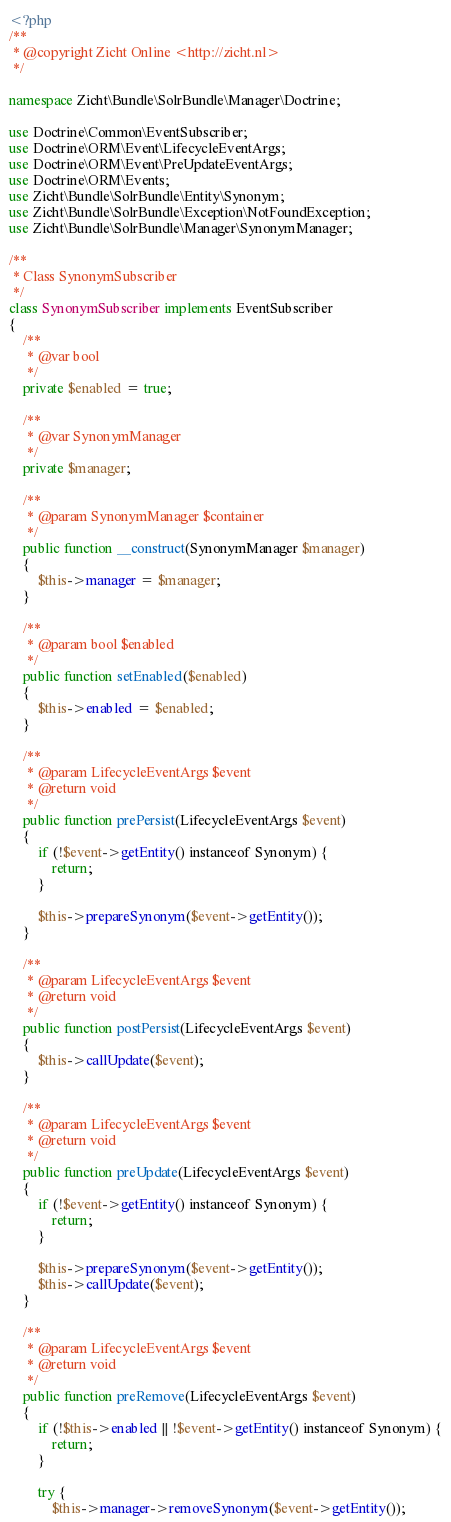<code> <loc_0><loc_0><loc_500><loc_500><_PHP_><?php
/**
 * @copyright Zicht Online <http://zicht.nl>
 */

namespace Zicht\Bundle\SolrBundle\Manager\Doctrine;

use Doctrine\Common\EventSubscriber;
use Doctrine\ORM\Event\LifecycleEventArgs;
use Doctrine\ORM\Event\PreUpdateEventArgs;
use Doctrine\ORM\Events;
use Zicht\Bundle\SolrBundle\Entity\Synonym;
use Zicht\Bundle\SolrBundle\Exception\NotFoundException;
use Zicht\Bundle\SolrBundle\Manager\SynonymManager;

/**
 * Class SynonymSubscriber
 */
class SynonymSubscriber implements EventSubscriber
{
    /**
     * @var bool
     */
    private $enabled = true;

    /**
     * @var SynonymManager
     */
    private $manager;

    /**
     * @param SynonymManager $container
     */
    public function __construct(SynonymManager $manager)
    {
        $this->manager = $manager;
    }

    /**
     * @param bool $enabled
     */
    public function setEnabled($enabled)
    {
        $this->enabled = $enabled;
    }

    /**
     * @param LifecycleEventArgs $event
     * @return void
     */
    public function prePersist(LifecycleEventArgs $event)
    {
        if (!$event->getEntity() instanceof Synonym) {
            return;
        }

        $this->prepareSynonym($event->getEntity());
    }

    /**
     * @param LifecycleEventArgs $event
     * @return void
     */
    public function postPersist(LifecycleEventArgs $event)
    {
        $this->callUpdate($event);
    }

    /**
     * @param LifecycleEventArgs $event
     * @return void
     */
    public function preUpdate(LifecycleEventArgs $event)
    {
        if (!$event->getEntity() instanceof Synonym) {
            return;
        }

        $this->prepareSynonym($event->getEntity());
        $this->callUpdate($event);
    }

    /**
     * @param LifecycleEventArgs $event
     * @return void
     */
    public function preRemove(LifecycleEventArgs $event)
    {
        if (!$this->enabled || !$event->getEntity() instanceof Synonym) {
            return;
        }

        try {
            $this->manager->removeSynonym($event->getEntity());</code> 